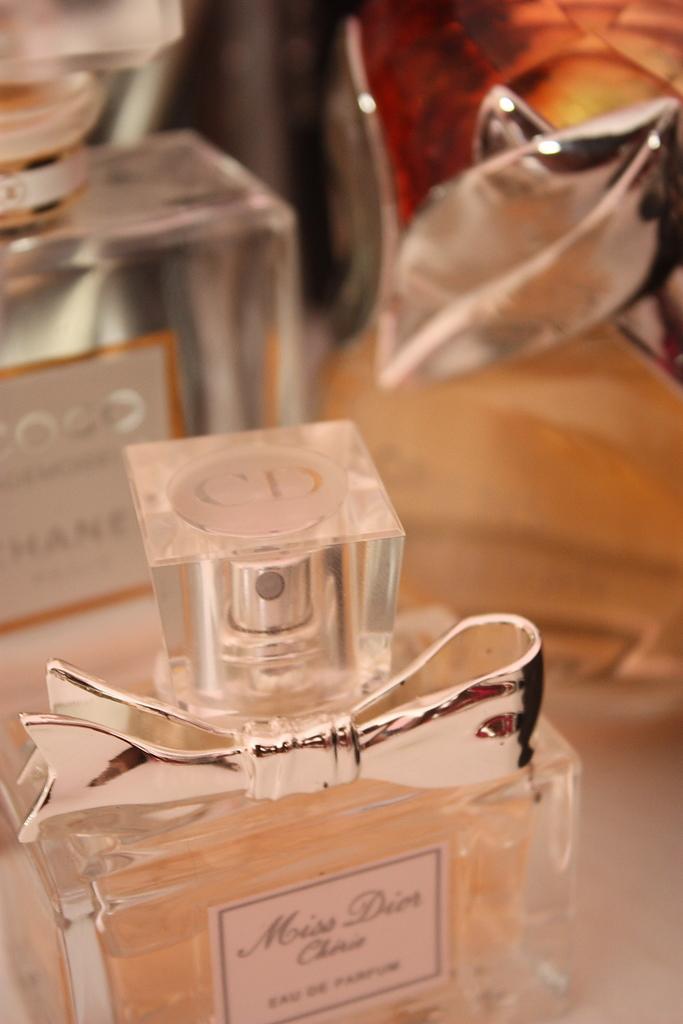What is the name of the perfume?
Offer a very short reply. Miss dior. What are the initials on the cap of this perfume?
Your answer should be compact. Cd. 